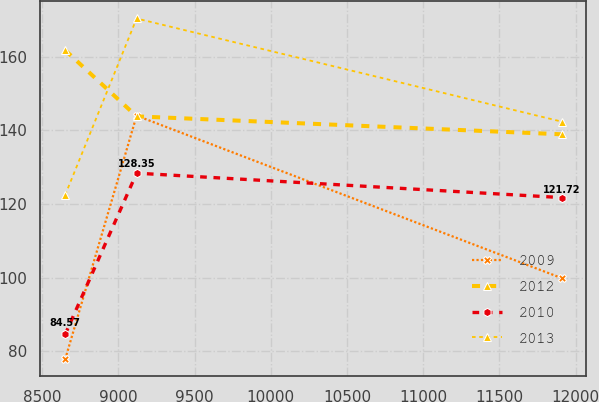Convert chart. <chart><loc_0><loc_0><loc_500><loc_500><line_chart><ecel><fcel>2009<fcel>2012<fcel>2010<fcel>2013<nl><fcel>8650.93<fcel>77.81<fcel>161.72<fcel>84.57<fcel>122.43<nl><fcel>9119.6<fcel>143.96<fcel>143.77<fcel>128.35<fcel>170.34<nl><fcel>11908<fcel>99.86<fcel>138.9<fcel>121.72<fcel>142.35<nl></chart> 